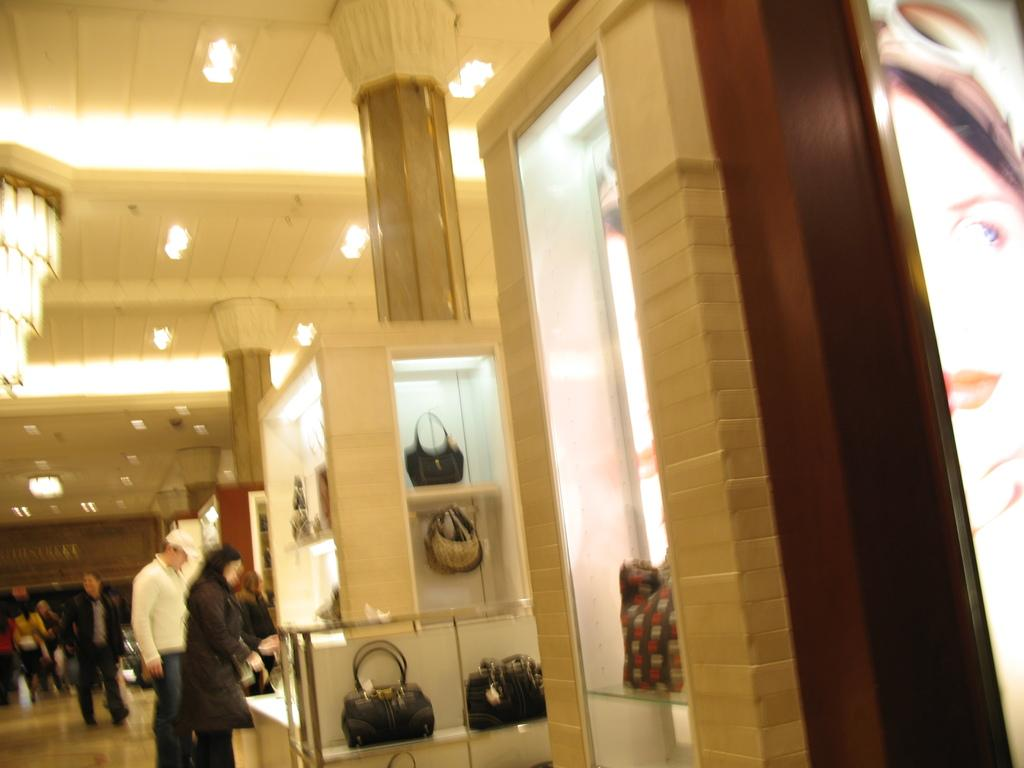How many people are in the image? There are people in the image, but the exact number is not specified. What items can be seen with the people in the image? Handbags are visible in the image. What type of object is made of glass in the image? There is a glass object in the image, but its specific purpose or appearance is not mentioned. What architectural feature can be seen in the image? There is a wall in the image. What additional decorative element is present in the image? There is a banner in the image. What structural elements are present in the image? Pillars are visible in the image. What type of lighting fixture is present in the image? There is a chandelier in the image. What type of ceiling is present in the image? There is a ceiling with lights in the image. What subject is being taught in the image? There is no indication of teaching or any educational activity in the image. What type of attraction is present in the image? There is no specific attraction mentioned or depicted in the image. 